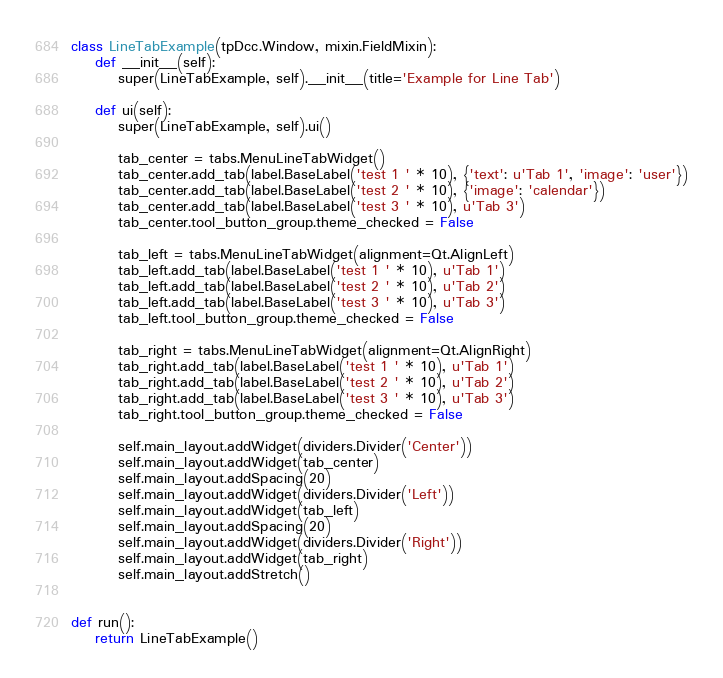Convert code to text. <code><loc_0><loc_0><loc_500><loc_500><_Python_>
class LineTabExample(tpDcc.Window, mixin.FieldMixin):
    def __init__(self):
        super(LineTabExample, self).__init__(title='Example for Line Tab')

    def ui(self):
        super(LineTabExample, self).ui()

        tab_center = tabs.MenuLineTabWidget()
        tab_center.add_tab(label.BaseLabel('test 1 ' * 10), {'text': u'Tab 1', 'image': 'user'})
        tab_center.add_tab(label.BaseLabel('test 2 ' * 10), {'image': 'calendar'})
        tab_center.add_tab(label.BaseLabel('test 3 ' * 10), u'Tab 3')
        tab_center.tool_button_group.theme_checked = False

        tab_left = tabs.MenuLineTabWidget(alignment=Qt.AlignLeft)
        tab_left.add_tab(label.BaseLabel('test 1 ' * 10), u'Tab 1')
        tab_left.add_tab(label.BaseLabel('test 2 ' * 10), u'Tab 2')
        tab_left.add_tab(label.BaseLabel('test 3 ' * 10), u'Tab 3')
        tab_left.tool_button_group.theme_checked = False

        tab_right = tabs.MenuLineTabWidget(alignment=Qt.AlignRight)
        tab_right.add_tab(label.BaseLabel('test 1 ' * 10), u'Tab 1')
        tab_right.add_tab(label.BaseLabel('test 2 ' * 10), u'Tab 2')
        tab_right.add_tab(label.BaseLabel('test 3 ' * 10), u'Tab 3')
        tab_right.tool_button_group.theme_checked = False

        self.main_layout.addWidget(dividers.Divider('Center'))
        self.main_layout.addWidget(tab_center)
        self.main_layout.addSpacing(20)
        self.main_layout.addWidget(dividers.Divider('Left'))
        self.main_layout.addWidget(tab_left)
        self.main_layout.addSpacing(20)
        self.main_layout.addWidget(dividers.Divider('Right'))
        self.main_layout.addWidget(tab_right)
        self.main_layout.addStretch()


def run():
    return LineTabExample()
</code> 